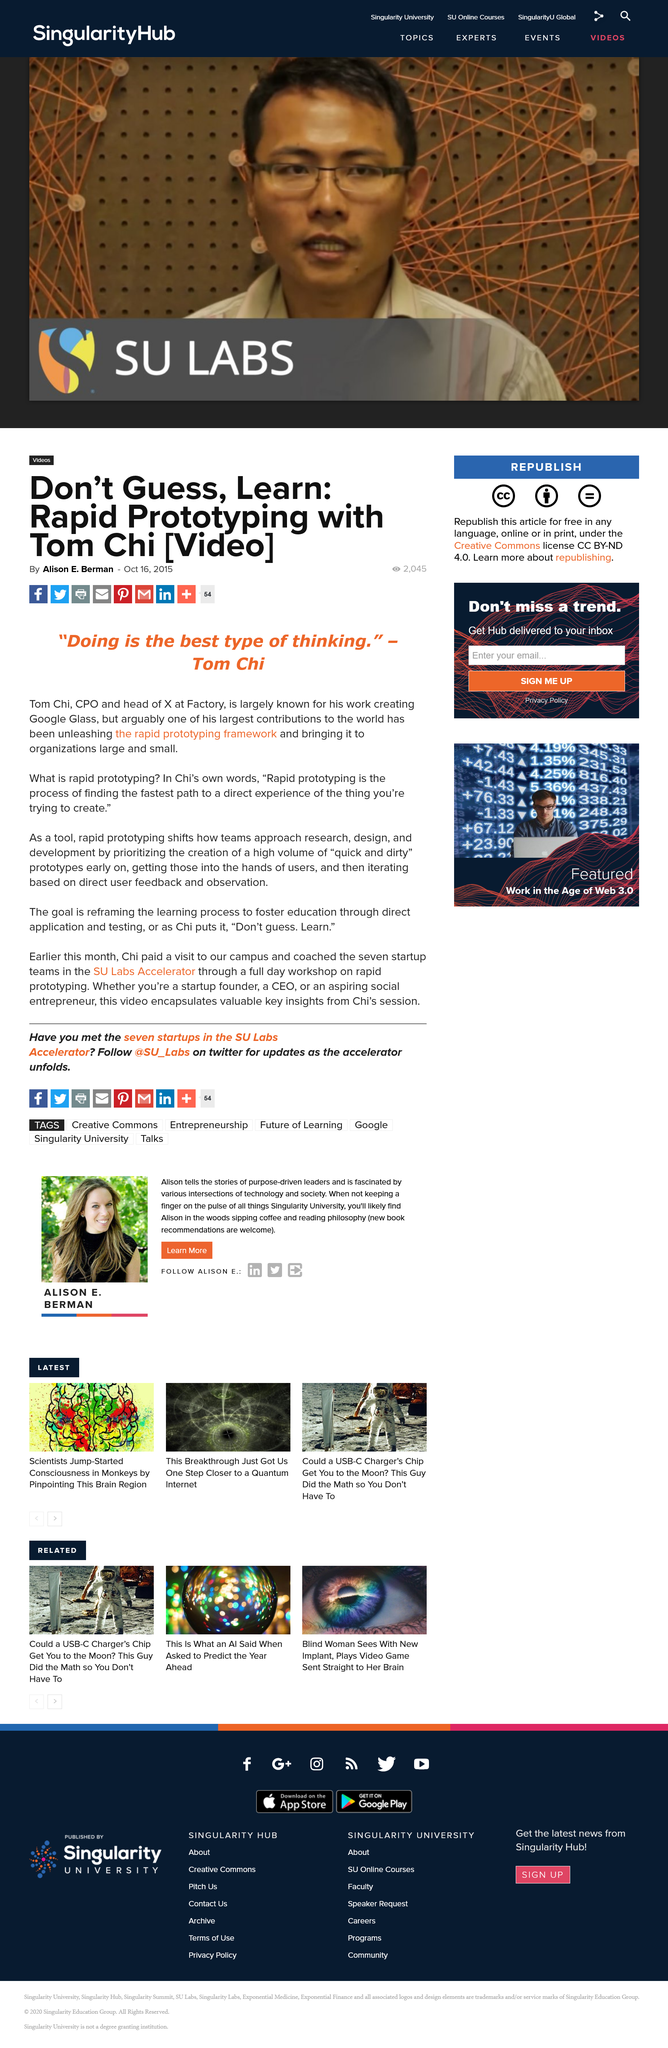Give some essential details in this illustration. The article titled "Don't guess, Learn: rapid prototyping with tom chi [video]?" received 2045 views. Tom Chi is the Chief Product Officer and head of X Factory. 